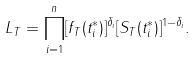<formula> <loc_0><loc_0><loc_500><loc_500>L _ { T } = \prod _ { i = 1 } ^ { n } [ f _ { T } ( t _ { i } ^ { \ast } ) ] ^ { \delta _ { i } } [ S _ { T } ( t _ { i } ^ { \ast } ) ] ^ { 1 - \delta _ { i } } .</formula> 